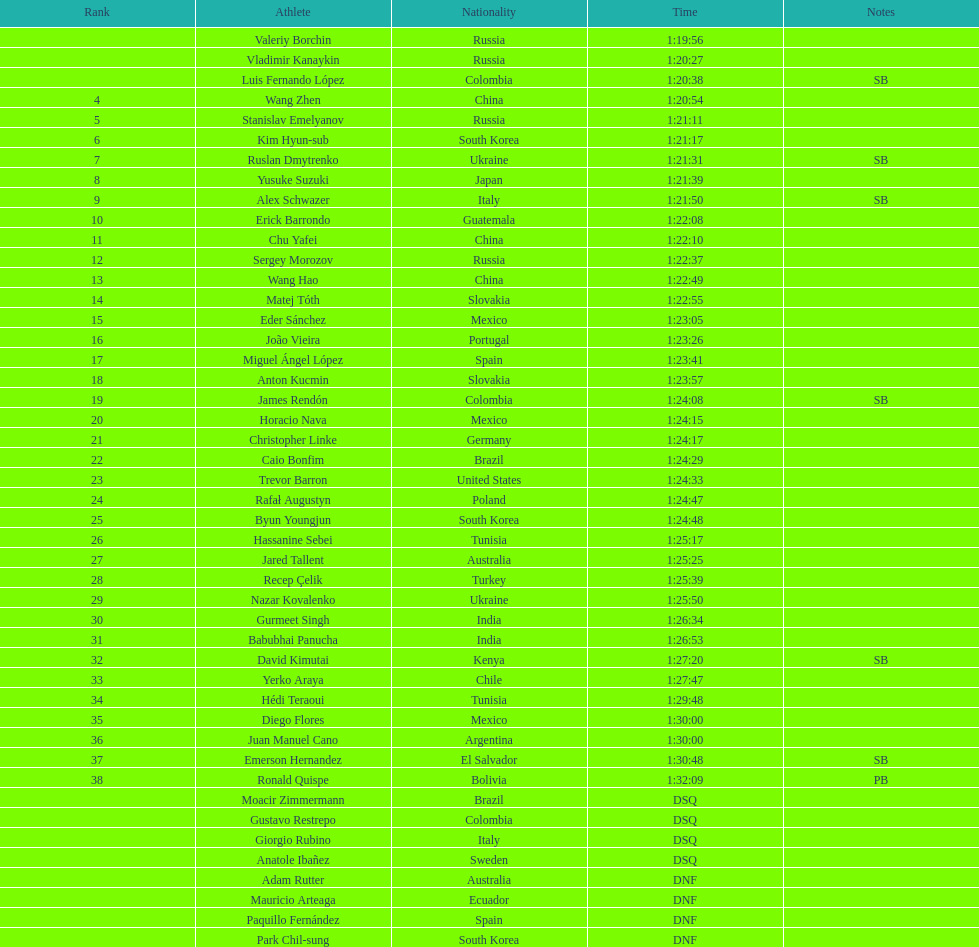Who was the competitor that achieved the first position? Valeriy Borchin. 